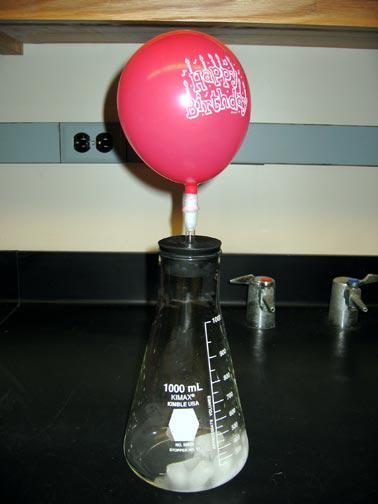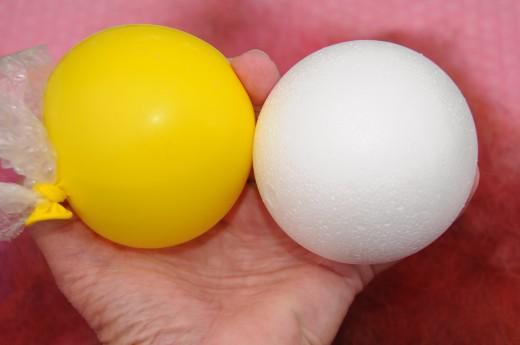The first image is the image on the left, the second image is the image on the right. Analyze the images presented: Is the assertion "A total of three balloons are shown, and one image contains only a pink-colored balloon." valid? Answer yes or no. Yes. The first image is the image on the left, the second image is the image on the right. Given the left and right images, does the statement "There are more balloons in the image on the right." hold true? Answer yes or no. Yes. 